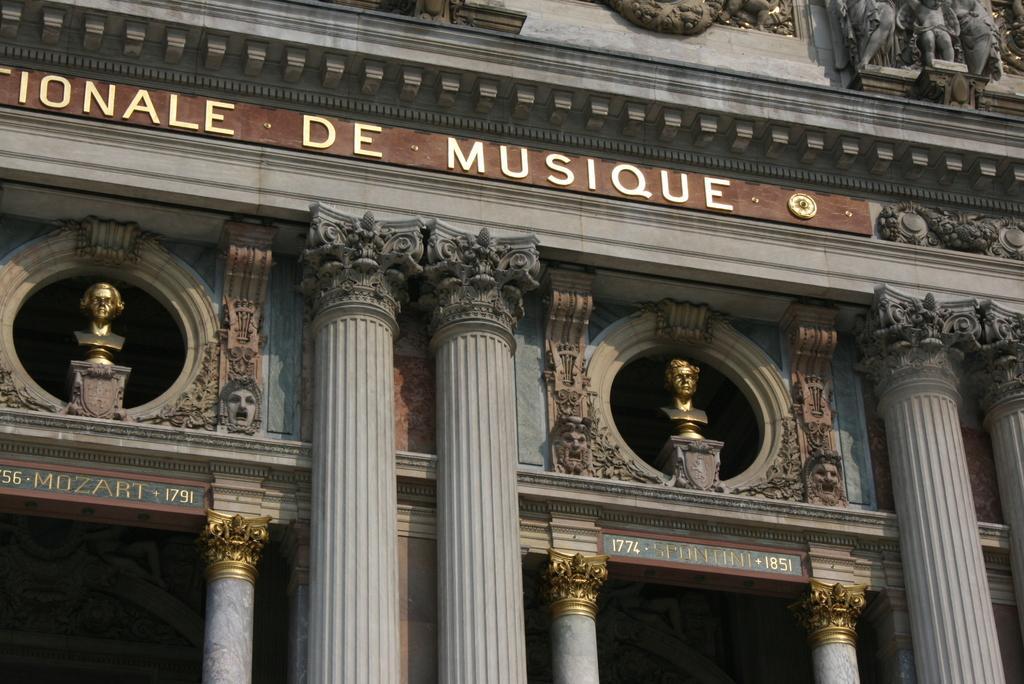Can you describe this image briefly? In this image, we can see some sculptures on the wall. We can also see some text. There are a few pillars. 